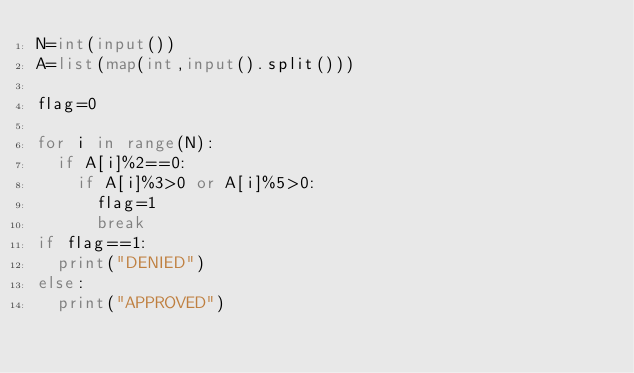<code> <loc_0><loc_0><loc_500><loc_500><_Python_>N=int(input())
A=list(map(int,input().split()))

flag=0

for i in range(N):
  if A[i]%2==0:
    if A[i]%3>0 or A[i]%5>0:
      flag=1
      break
if flag==1:
  print("DENIED")
else:
  print("APPROVED")</code> 